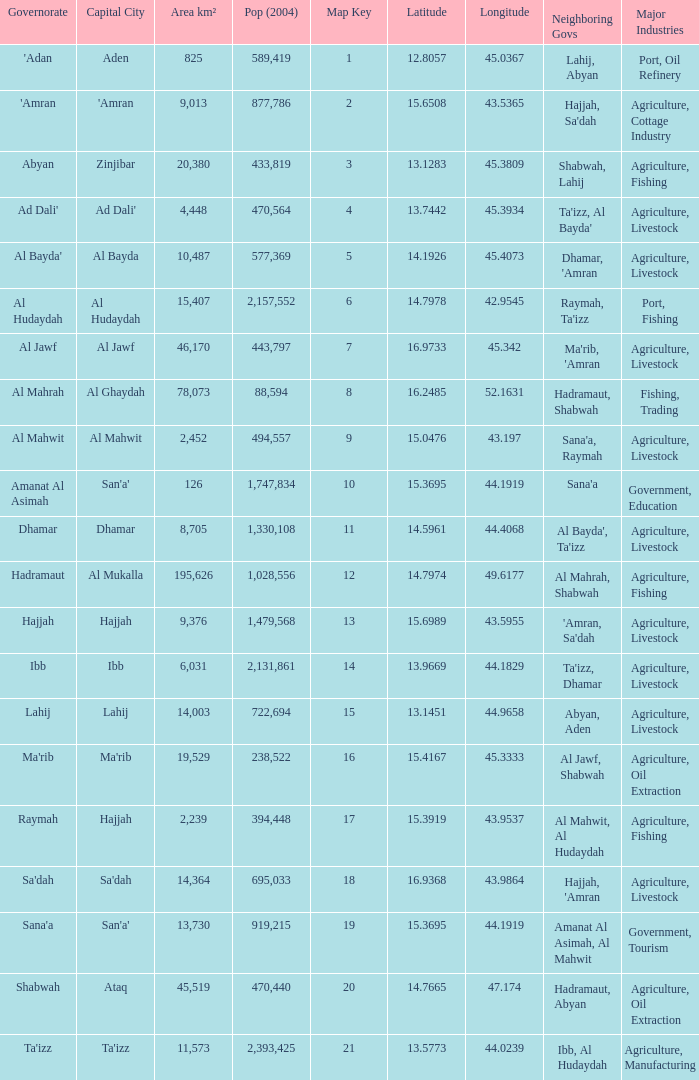How many Pop (2004) has a Governorate of al mahwit? 494557.0. 